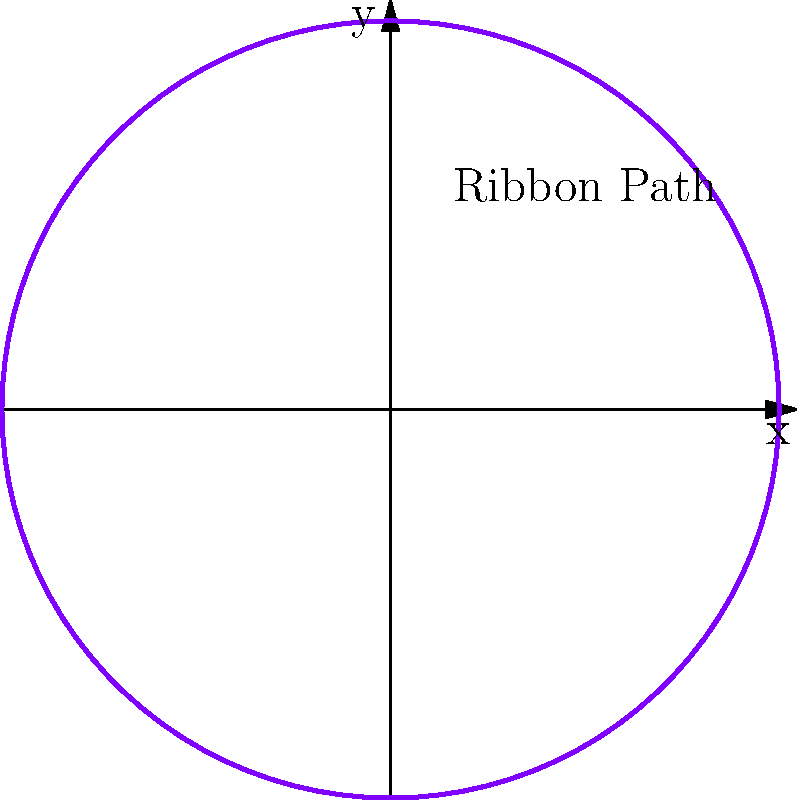In a rhythmic gymnastics routine, a ribbon follows a path described by the parametric equations $x = \sin(t)$ and $y = \cos(t)$ for $0 \leq t \leq 2\pi$. What topological property does this path exhibit, and how does it relate to the continuous deformation of the ribbon during the routine? Let's analyze this step-by-step:

1. The parametric equations $x = \sin(t)$ and $y = \cos(t)$ for $0 \leq t \leq 2\pi$ describe a circle in the xy-plane.

2. In topology, a circle is considered a closed curve without self-intersections.

3. The path is continuous, meaning there are no breaks or jumps in the ribbon's movement.

4. As the parameter t increases from 0 to 2π, the point (x,y) traces the entire circle exactly once.

5. This path is homeomorphic to a circle, meaning it can be continuously deformed into a perfect circle without breaking or gluing.

6. In the context of the rhythmic gymnastics routine, this implies that the ribbon's movement forms a closed loop that returns to its starting position.

7. The continuous nature of this path reflects the smooth, uninterrupted motion of the ribbon during the routine.

8. Topologically, this path is classified as a simple closed curve, which is a fundamental concept in topology.

9. The Jordan Curve Theorem, a key result in topology, applies to this path, stating that it divides the plane into two regions: an "inside" and an "outside."

10. The ribbon's movement demonstrates the concept of a homotopy in topology, as it can be continuously deformed while maintaining its essential topological properties.
Answer: Simple closed curve (topologically equivalent to a circle) 